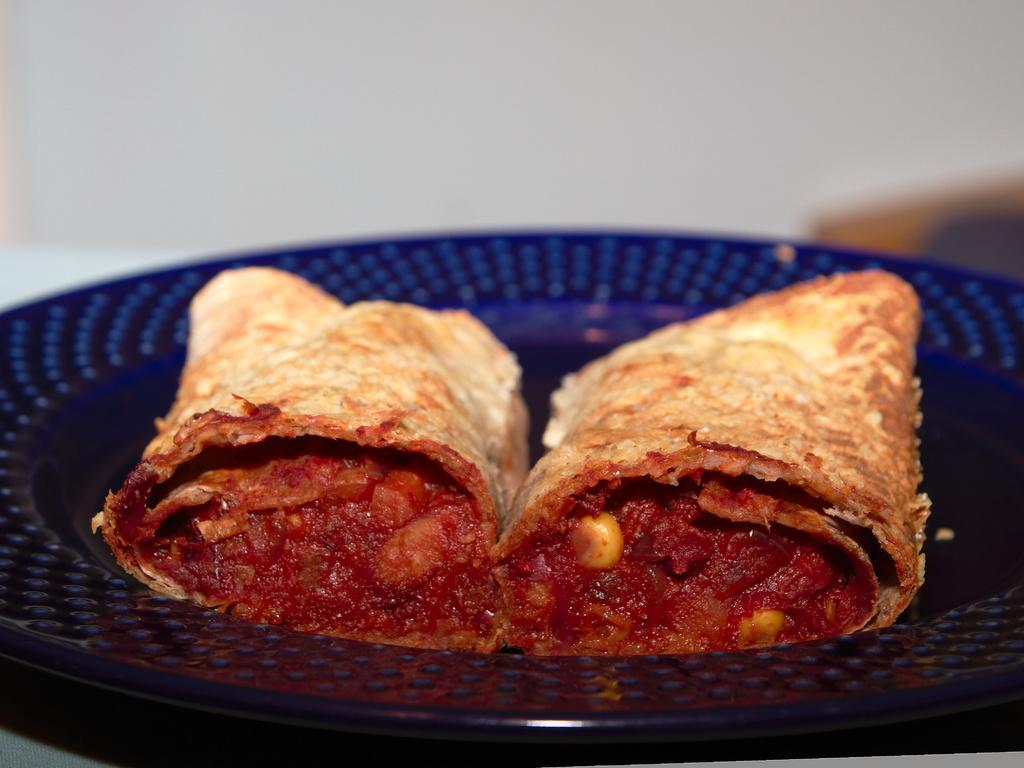What color is the plate that is visible in the image? The plate is blue in color. What is on the plate in the image? There is food on the plate. Can you describe the overall quality of the image? The image is slightly blurry in the background. How many dimes can be seen on the plate in the image? There are no dimes present on the plate in the image; it only contains food. 